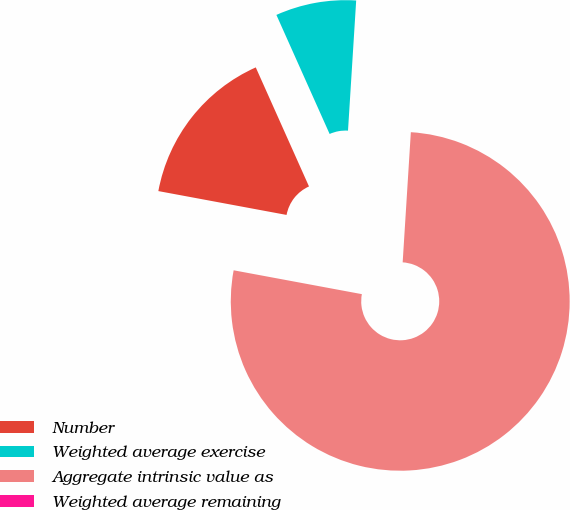<chart> <loc_0><loc_0><loc_500><loc_500><pie_chart><fcel>Number<fcel>Weighted average exercise<fcel>Aggregate intrinsic value as<fcel>Weighted average remaining<nl><fcel>15.38%<fcel>7.69%<fcel>76.92%<fcel>0.0%<nl></chart> 